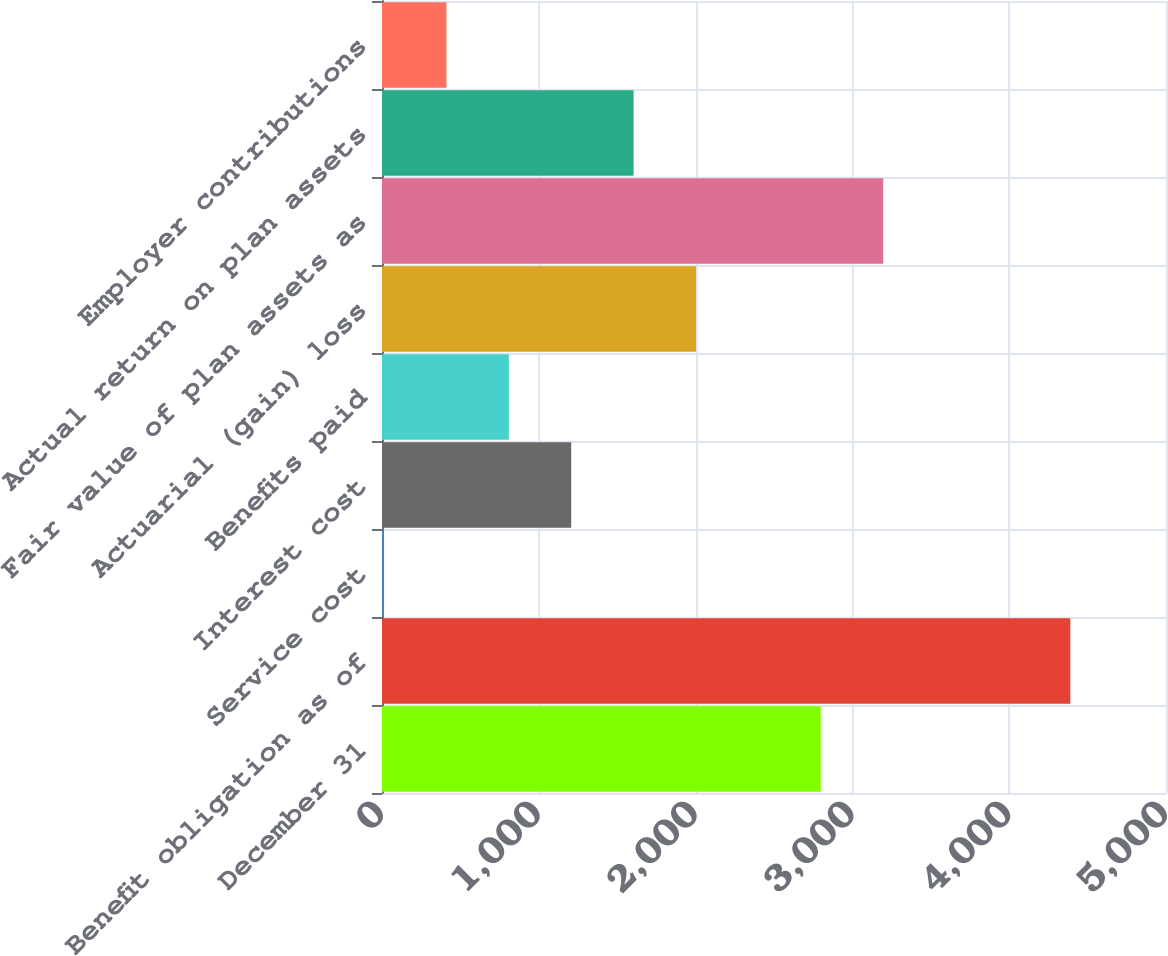<chart> <loc_0><loc_0><loc_500><loc_500><bar_chart><fcel>December 31<fcel>Benefit obligation as of<fcel>Service cost<fcel>Interest cost<fcel>Benefits paid<fcel>Actuarial (gain) loss<fcel>Fair value of plan assets as<fcel>Actual return on plan assets<fcel>Employer contributions<nl><fcel>2798.3<fcel>4389.9<fcel>13<fcel>1206.7<fcel>808.8<fcel>2002.5<fcel>3196.2<fcel>1604.6<fcel>410.9<nl></chart> 